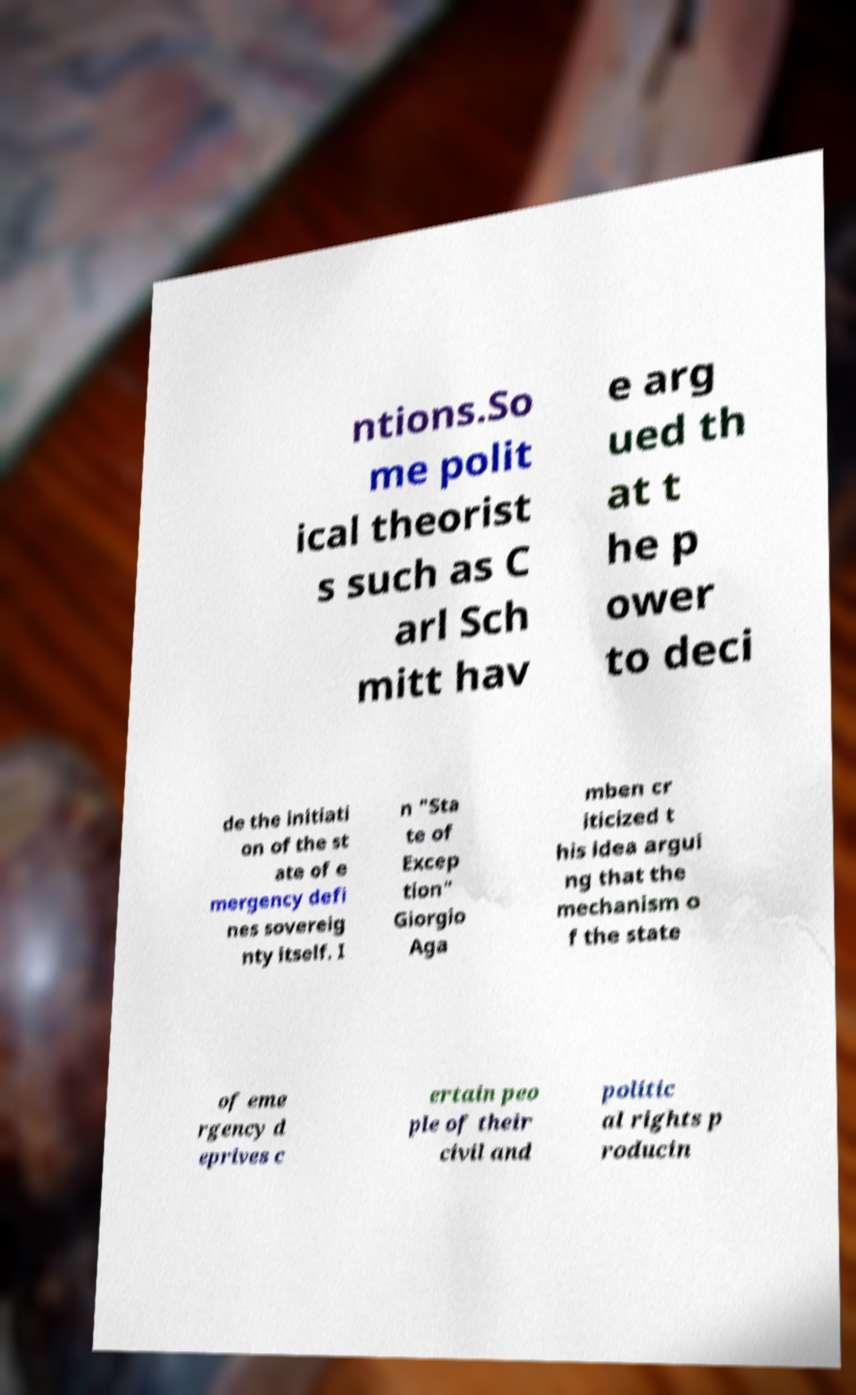Can you accurately transcribe the text from the provided image for me? ntions.So me polit ical theorist s such as C arl Sch mitt hav e arg ued th at t he p ower to deci de the initiati on of the st ate of e mergency defi nes sovereig nty itself. I n "Sta te of Excep tion" Giorgio Aga mben cr iticized t his idea argui ng that the mechanism o f the state of eme rgency d eprives c ertain peo ple of their civil and politic al rights p roducin 